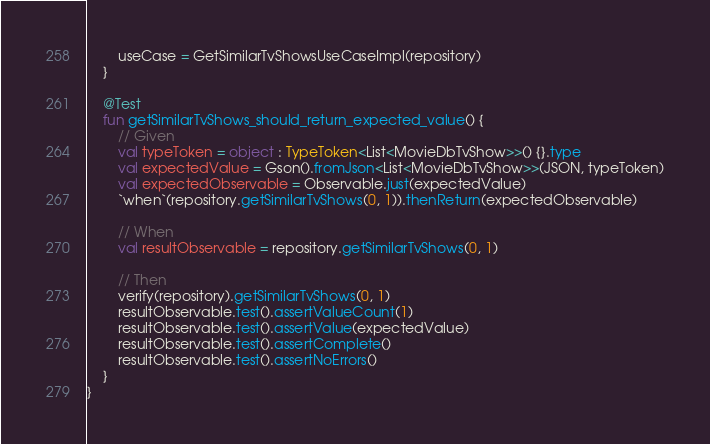<code> <loc_0><loc_0><loc_500><loc_500><_Kotlin_>        useCase = GetSimilarTvShowsUseCaseImpl(repository)
    }

    @Test
    fun getSimilarTvShows_should_return_expected_value() {
        // Given
        val typeToken = object : TypeToken<List<MovieDbTvShow>>() {}.type
        val expectedValue = Gson().fromJson<List<MovieDbTvShow>>(JSON, typeToken)
        val expectedObservable = Observable.just(expectedValue)
        `when`(repository.getSimilarTvShows(0, 1)).thenReturn(expectedObservable)

        // When
        val resultObservable = repository.getSimilarTvShows(0, 1)

        // Then
        verify(repository).getSimilarTvShows(0, 1)
        resultObservable.test().assertValueCount(1)
        resultObservable.test().assertValue(expectedValue)
        resultObservable.test().assertComplete()
        resultObservable.test().assertNoErrors()
    }
}</code> 